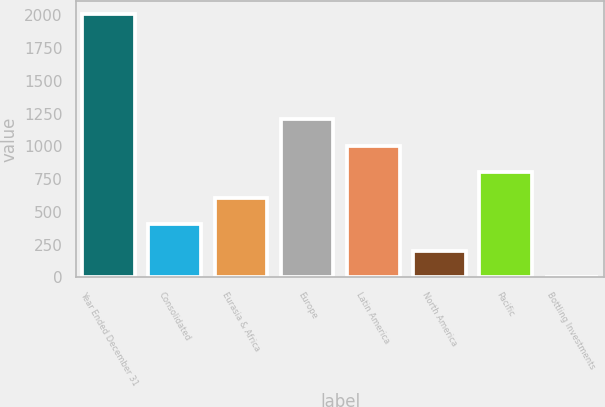Convert chart. <chart><loc_0><loc_0><loc_500><loc_500><bar_chart><fcel>Year Ended December 31<fcel>Consolidated<fcel>Eurasia & Africa<fcel>Europe<fcel>Latin America<fcel>North America<fcel>Pacific<fcel>Bottling Investments<nl><fcel>2009<fcel>403.56<fcel>604.24<fcel>1206.28<fcel>1005.6<fcel>202.88<fcel>804.92<fcel>2.2<nl></chart> 